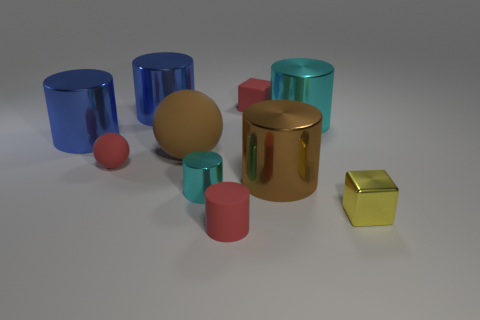Can you describe the colors and shapes present in the image? Certainly! The image features a variety of geometric shapes including cylinders and cubes. The cylinders come in various colors such as blue, teal, pink, and brown with different finishes like matte and metallic. The cubes have a metallic finish and appear in gold and yellow colors. 